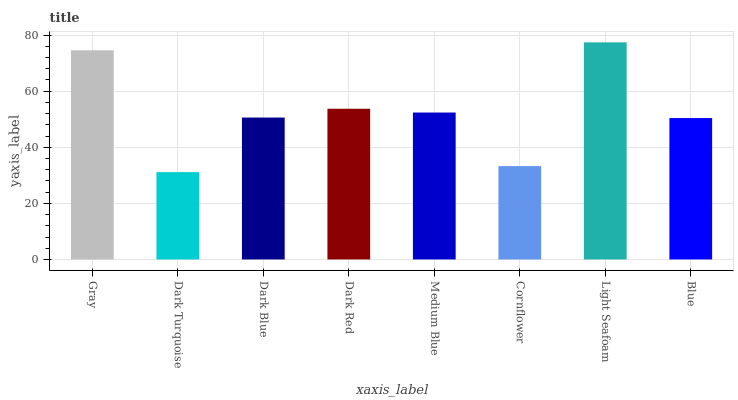Is Dark Turquoise the minimum?
Answer yes or no. Yes. Is Light Seafoam the maximum?
Answer yes or no. Yes. Is Dark Blue the minimum?
Answer yes or no. No. Is Dark Blue the maximum?
Answer yes or no. No. Is Dark Blue greater than Dark Turquoise?
Answer yes or no. Yes. Is Dark Turquoise less than Dark Blue?
Answer yes or no. Yes. Is Dark Turquoise greater than Dark Blue?
Answer yes or no. No. Is Dark Blue less than Dark Turquoise?
Answer yes or no. No. Is Medium Blue the high median?
Answer yes or no. Yes. Is Dark Blue the low median?
Answer yes or no. Yes. Is Gray the high median?
Answer yes or no. No. Is Gray the low median?
Answer yes or no. No. 